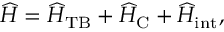<formula> <loc_0><loc_0><loc_500><loc_500>\widehat { H } = \widehat { H } _ { T B } + \widehat { H } _ { C } + \widehat { H } _ { i n t } ,</formula> 